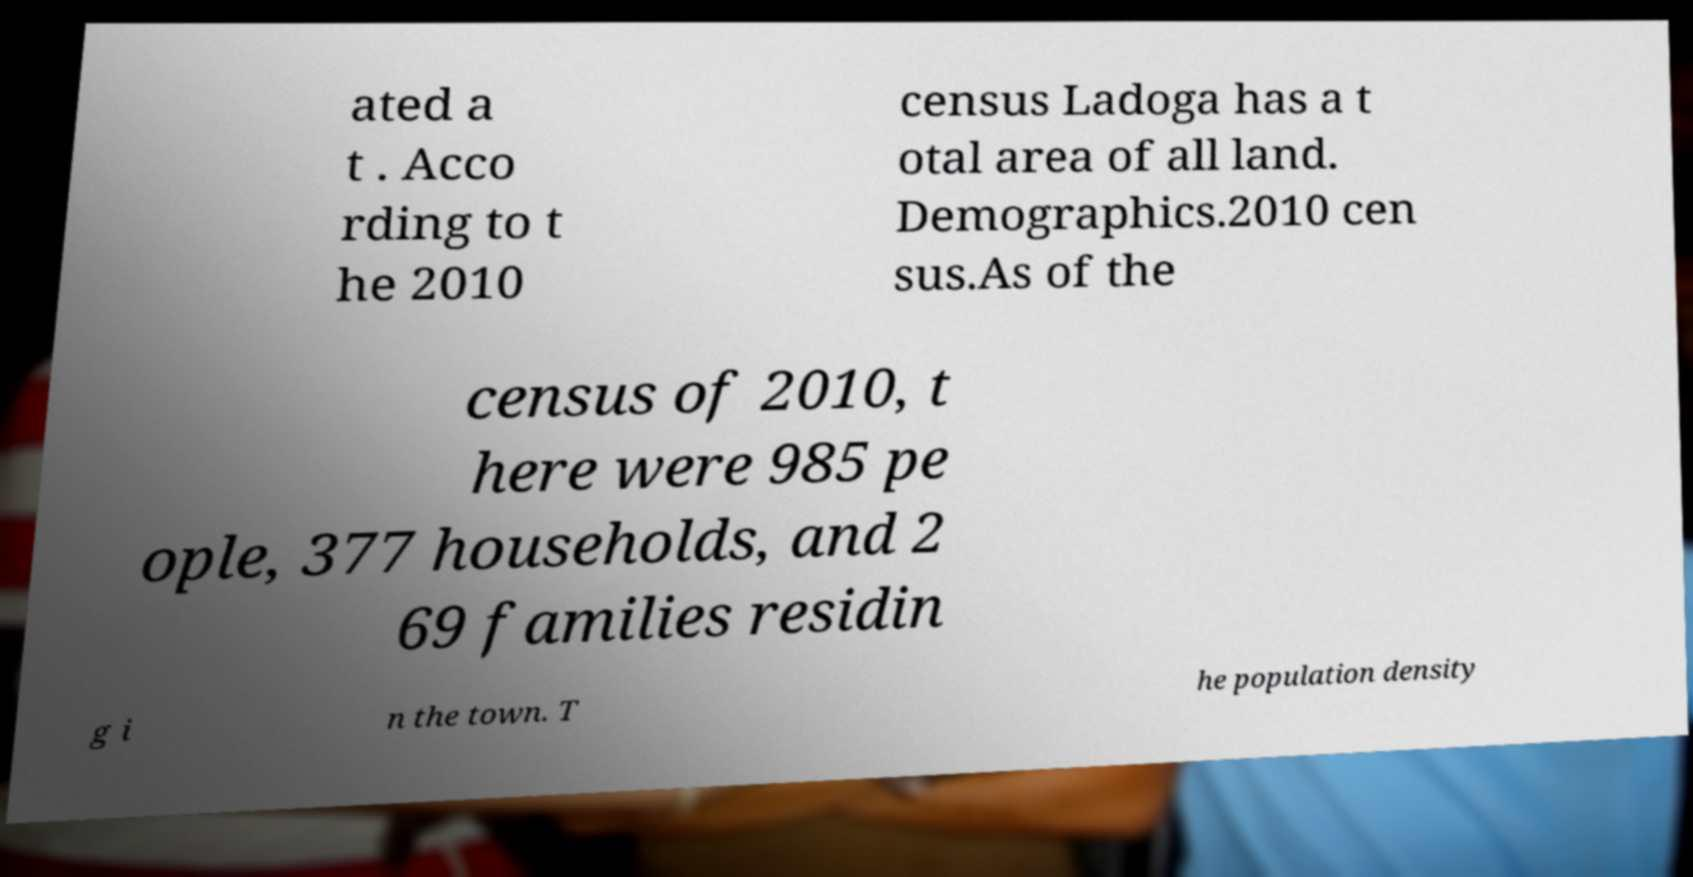What messages or text are displayed in this image? I need them in a readable, typed format. ated a t . Acco rding to t he 2010 census Ladoga has a t otal area of all land. Demographics.2010 cen sus.As of the census of 2010, t here were 985 pe ople, 377 households, and 2 69 families residin g i n the town. T he population density 